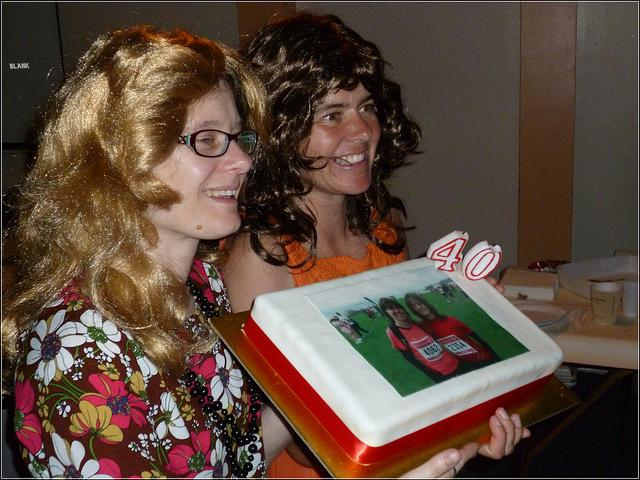How old is the birthday girl?

Choices:
A) 30
B) ten
C) 20
D) 40 40 